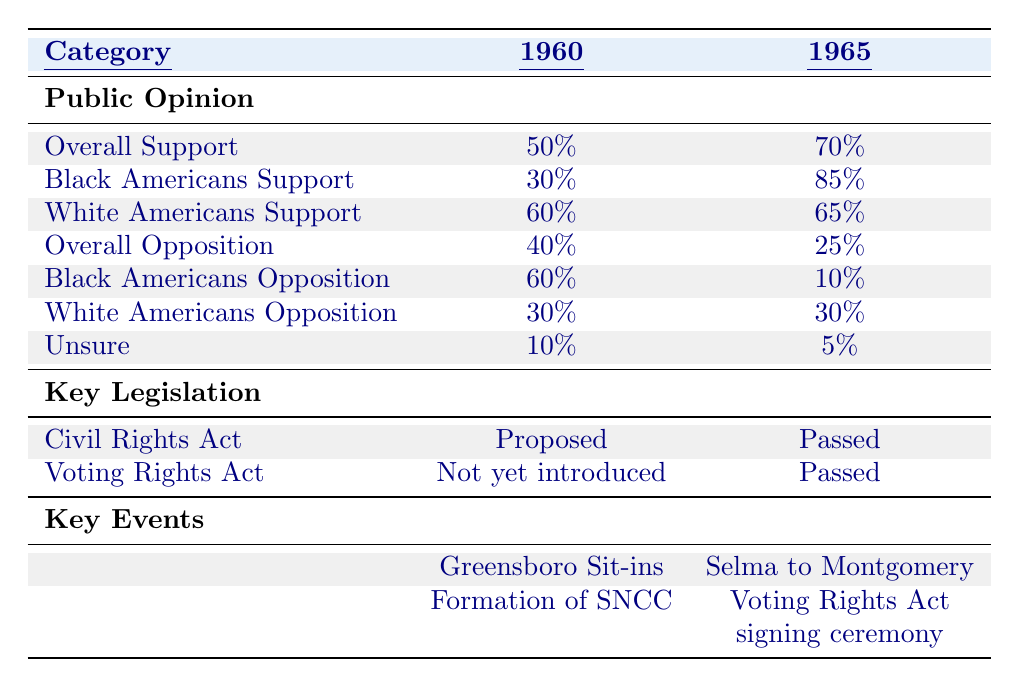What was the overall support for civil rights legislation in 1960? The table shows the overall support for civil rights legislation in 1960 as 50%.
Answer: 50% What percentage of Black Americans supported civil rights in 1965? The table indicates that 85% of Black Americans supported civil rights legislation in 1965.
Answer: 85% Was the Voting Rights Act introduced by 1960? The table states that the Voting Rights Act was not yet introduced in 1960, indicating that the statement is true.
Answer: No What is the difference in overall support for civil rights legislation between 1960 and 1965? In 1960, the overall support was 50%, and in 1965 it was 70%. The difference is 70% - 50% = 20%.
Answer: 20% What percentage of White Americans opposed civil rights legislation in 1965? According to the table, 30% of White Americans opposed civil rights legislation in 1965.
Answer: 30% What percentage of people were unsure about civil rights in 1960 and in 1965? The table shows that 10% were unsure in 1960 and 5% in 1965.
Answer: 10% in 1960 and 5% in 1965 Which group showed the largest increase in support from 1960 to 1965? Analyzing the data, Black Americans increased their support from 30% to 85%, a significant increase of 55%.
Answer: Black Americans How did the support for civil rights legislation compare between Black and White Americans in 1965? In 1965, 85% of Black Americans and 65% of White Americans supported civil rights legislation, showing that Black Americans had higher support.
Answer: Black Americans had higher support Was the Civil Rights Act passed by 1965? According to the table, the Civil Rights Act was passed by 1965, confirming that this statement is true.
Answer: Yes How much did the overall opposition decrease from 1960 to 1965? The overall opposition in 1960 was 40% and decreased to 25% in 1965. The decrease is 40% - 25% = 15%.
Answer: 15% What key events are listed for the year 1965? The table lists the Selma to Montgomery marches and the Voting Rights Act signing ceremony as key events for 1965.
Answer: Selma to Montgomery marches and Voting Rights Act signing ceremony 